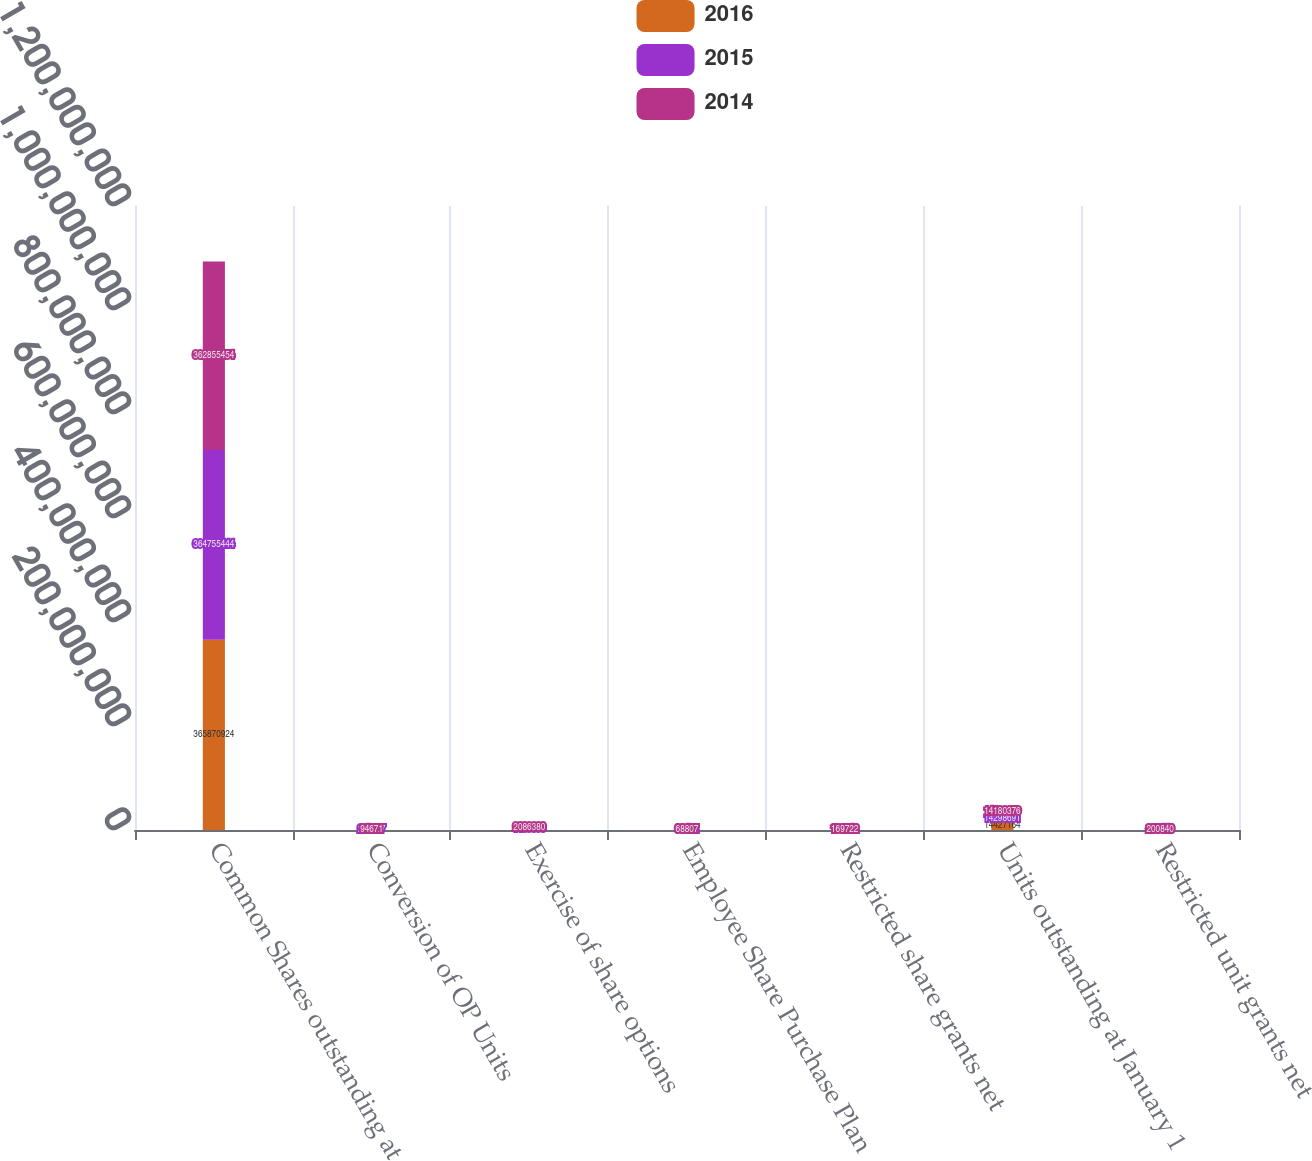<chart> <loc_0><loc_0><loc_500><loc_500><stacked_bar_chart><ecel><fcel>Common Shares outstanding at<fcel>Conversion of OP Units<fcel>Exercise of share options<fcel>Employee Share Purchase Plan<fcel>Restricted share grants net<fcel>Units outstanding at January 1<fcel>Restricted unit grants net<nl><fcel>2016<fcel>3.65871e+08<fcel>88838<fcel>815044<fcel>63909<fcel>147689<fcel>1.44272e+07<fcel>287749<nl><fcel>2015<fcel>3.64755e+08<fcel>208307<fcel>1.45636e+06<fcel>68462<fcel>168142<fcel>1.42987e+07<fcel>335496<nl><fcel>2014<fcel>3.62855e+08<fcel>94671<fcel>2.08638e+06<fcel>68807<fcel>169722<fcel>1.41804e+07<fcel>200840<nl></chart> 